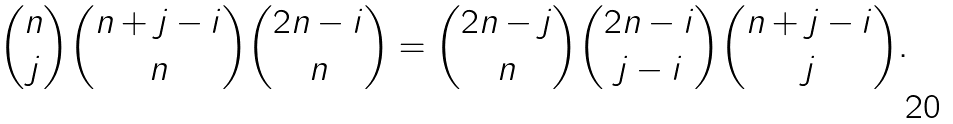<formula> <loc_0><loc_0><loc_500><loc_500>\binom { n } { j } \binom { n + j - i } { n } \binom { 2 n - i } { n } = \binom { 2 n - j } { n } \binom { 2 n - i } { j - i } \binom { n + j - i } { j } .</formula> 